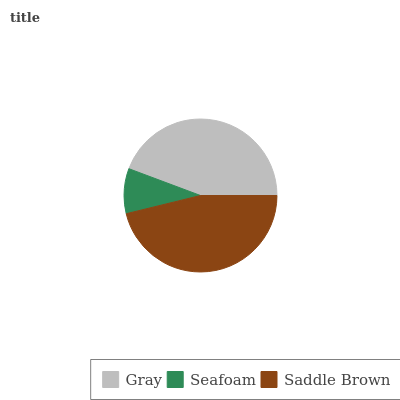Is Seafoam the minimum?
Answer yes or no. Yes. Is Saddle Brown the maximum?
Answer yes or no. Yes. Is Saddle Brown the minimum?
Answer yes or no. No. Is Seafoam the maximum?
Answer yes or no. No. Is Saddle Brown greater than Seafoam?
Answer yes or no. Yes. Is Seafoam less than Saddle Brown?
Answer yes or no. Yes. Is Seafoam greater than Saddle Brown?
Answer yes or no. No. Is Saddle Brown less than Seafoam?
Answer yes or no. No. Is Gray the high median?
Answer yes or no. Yes. Is Gray the low median?
Answer yes or no. Yes. Is Seafoam the high median?
Answer yes or no. No. Is Saddle Brown the low median?
Answer yes or no. No. 